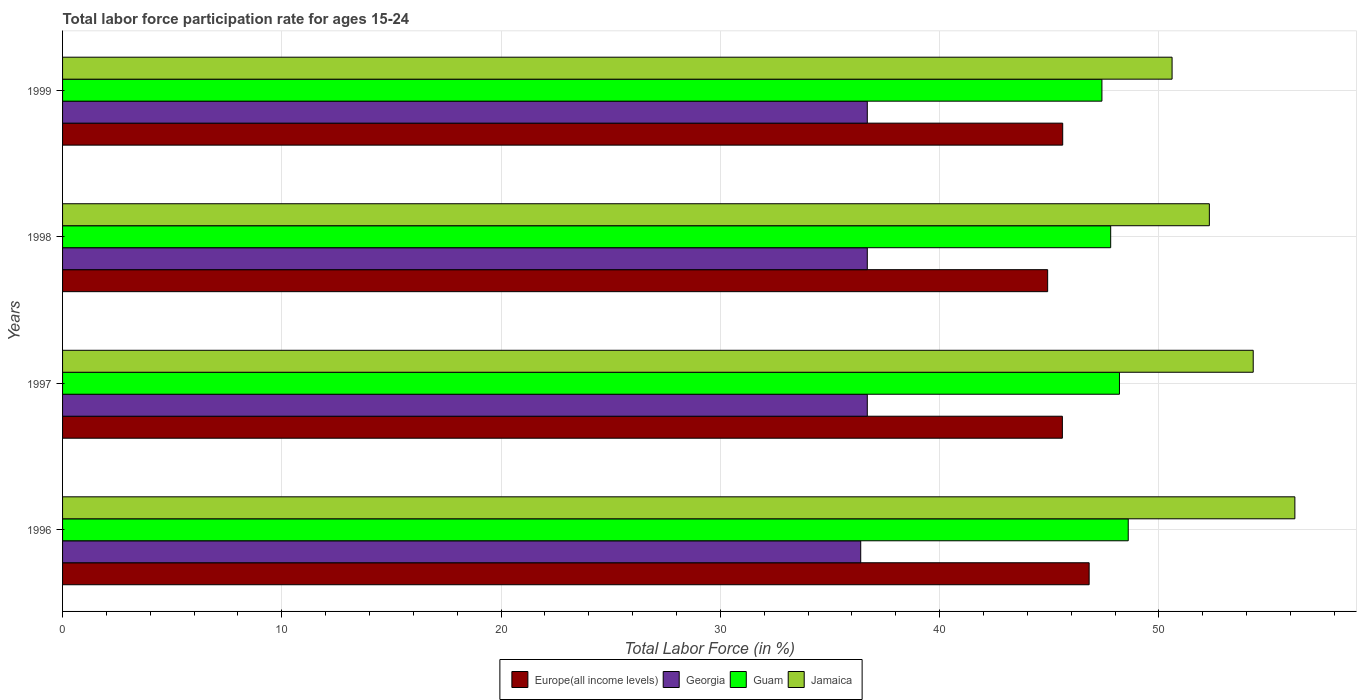Are the number of bars on each tick of the Y-axis equal?
Make the answer very short. Yes. What is the label of the 4th group of bars from the top?
Provide a short and direct response. 1996. What is the labor force participation rate in Georgia in 1996?
Ensure brevity in your answer.  36.4. Across all years, what is the maximum labor force participation rate in Guam?
Your answer should be compact. 48.6. Across all years, what is the minimum labor force participation rate in Guam?
Your response must be concise. 47.4. In which year was the labor force participation rate in Europe(all income levels) maximum?
Your answer should be very brief. 1996. In which year was the labor force participation rate in Guam minimum?
Offer a terse response. 1999. What is the total labor force participation rate in Europe(all income levels) in the graph?
Your answer should be compact. 182.95. What is the difference between the labor force participation rate in Jamaica in 1996 and that in 1997?
Your answer should be very brief. 1.9. What is the difference between the labor force participation rate in Georgia in 1996 and the labor force participation rate in Jamaica in 1998?
Your response must be concise. -15.9. What is the average labor force participation rate in Jamaica per year?
Give a very brief answer. 53.35. In the year 1997, what is the difference between the labor force participation rate in Guam and labor force participation rate in Europe(all income levels)?
Offer a very short reply. 2.6. What is the ratio of the labor force participation rate in Europe(all income levels) in 1996 to that in 1997?
Keep it short and to the point. 1.03. Is the difference between the labor force participation rate in Guam in 1996 and 1999 greater than the difference between the labor force participation rate in Europe(all income levels) in 1996 and 1999?
Your answer should be very brief. No. What is the difference between the highest and the second highest labor force participation rate in Georgia?
Offer a terse response. 0. What is the difference between the highest and the lowest labor force participation rate in Georgia?
Provide a short and direct response. 0.3. Is the sum of the labor force participation rate in Guam in 1996 and 1997 greater than the maximum labor force participation rate in Georgia across all years?
Make the answer very short. Yes. What does the 3rd bar from the top in 1998 represents?
Your response must be concise. Georgia. What does the 3rd bar from the bottom in 1997 represents?
Your answer should be compact. Guam. How many bars are there?
Offer a terse response. 16. Are all the bars in the graph horizontal?
Your answer should be compact. Yes. What is the difference between two consecutive major ticks on the X-axis?
Your answer should be compact. 10. Does the graph contain grids?
Give a very brief answer. Yes. What is the title of the graph?
Provide a succinct answer. Total labor force participation rate for ages 15-24. What is the label or title of the X-axis?
Your answer should be very brief. Total Labor Force (in %). What is the label or title of the Y-axis?
Offer a terse response. Years. What is the Total Labor Force (in %) in Europe(all income levels) in 1996?
Your answer should be compact. 46.82. What is the Total Labor Force (in %) in Georgia in 1996?
Make the answer very short. 36.4. What is the Total Labor Force (in %) of Guam in 1996?
Provide a succinct answer. 48.6. What is the Total Labor Force (in %) in Jamaica in 1996?
Your answer should be compact. 56.2. What is the Total Labor Force (in %) in Europe(all income levels) in 1997?
Your response must be concise. 45.6. What is the Total Labor Force (in %) of Georgia in 1997?
Keep it short and to the point. 36.7. What is the Total Labor Force (in %) of Guam in 1997?
Provide a short and direct response. 48.2. What is the Total Labor Force (in %) in Jamaica in 1997?
Ensure brevity in your answer.  54.3. What is the Total Labor Force (in %) of Europe(all income levels) in 1998?
Offer a very short reply. 44.93. What is the Total Labor Force (in %) of Georgia in 1998?
Ensure brevity in your answer.  36.7. What is the Total Labor Force (in %) of Guam in 1998?
Make the answer very short. 47.8. What is the Total Labor Force (in %) of Jamaica in 1998?
Your response must be concise. 52.3. What is the Total Labor Force (in %) of Europe(all income levels) in 1999?
Your answer should be very brief. 45.61. What is the Total Labor Force (in %) in Georgia in 1999?
Provide a short and direct response. 36.7. What is the Total Labor Force (in %) of Guam in 1999?
Provide a short and direct response. 47.4. What is the Total Labor Force (in %) of Jamaica in 1999?
Keep it short and to the point. 50.6. Across all years, what is the maximum Total Labor Force (in %) of Europe(all income levels)?
Offer a very short reply. 46.82. Across all years, what is the maximum Total Labor Force (in %) of Georgia?
Provide a short and direct response. 36.7. Across all years, what is the maximum Total Labor Force (in %) of Guam?
Your response must be concise. 48.6. Across all years, what is the maximum Total Labor Force (in %) in Jamaica?
Make the answer very short. 56.2. Across all years, what is the minimum Total Labor Force (in %) of Europe(all income levels)?
Offer a very short reply. 44.93. Across all years, what is the minimum Total Labor Force (in %) in Georgia?
Your response must be concise. 36.4. Across all years, what is the minimum Total Labor Force (in %) of Guam?
Your answer should be compact. 47.4. Across all years, what is the minimum Total Labor Force (in %) in Jamaica?
Your answer should be compact. 50.6. What is the total Total Labor Force (in %) in Europe(all income levels) in the graph?
Your response must be concise. 182.95. What is the total Total Labor Force (in %) in Georgia in the graph?
Provide a short and direct response. 146.5. What is the total Total Labor Force (in %) in Guam in the graph?
Keep it short and to the point. 192. What is the total Total Labor Force (in %) of Jamaica in the graph?
Ensure brevity in your answer.  213.4. What is the difference between the Total Labor Force (in %) of Europe(all income levels) in 1996 and that in 1997?
Offer a very short reply. 1.22. What is the difference between the Total Labor Force (in %) of Jamaica in 1996 and that in 1997?
Your response must be concise. 1.9. What is the difference between the Total Labor Force (in %) of Europe(all income levels) in 1996 and that in 1998?
Your answer should be compact. 1.89. What is the difference between the Total Labor Force (in %) in Georgia in 1996 and that in 1998?
Provide a short and direct response. -0.3. What is the difference between the Total Labor Force (in %) in Guam in 1996 and that in 1998?
Offer a very short reply. 0.8. What is the difference between the Total Labor Force (in %) of Europe(all income levels) in 1996 and that in 1999?
Offer a very short reply. 1.21. What is the difference between the Total Labor Force (in %) of Georgia in 1996 and that in 1999?
Provide a succinct answer. -0.3. What is the difference between the Total Labor Force (in %) of Guam in 1996 and that in 1999?
Provide a short and direct response. 1.2. What is the difference between the Total Labor Force (in %) of Jamaica in 1996 and that in 1999?
Provide a short and direct response. 5.6. What is the difference between the Total Labor Force (in %) of Europe(all income levels) in 1997 and that in 1998?
Ensure brevity in your answer.  0.67. What is the difference between the Total Labor Force (in %) of Georgia in 1997 and that in 1998?
Offer a very short reply. 0. What is the difference between the Total Labor Force (in %) of Guam in 1997 and that in 1998?
Your response must be concise. 0.4. What is the difference between the Total Labor Force (in %) of Jamaica in 1997 and that in 1998?
Your response must be concise. 2. What is the difference between the Total Labor Force (in %) in Europe(all income levels) in 1997 and that in 1999?
Offer a terse response. -0.01. What is the difference between the Total Labor Force (in %) in Guam in 1997 and that in 1999?
Keep it short and to the point. 0.8. What is the difference between the Total Labor Force (in %) of Europe(all income levels) in 1998 and that in 1999?
Make the answer very short. -0.69. What is the difference between the Total Labor Force (in %) of Georgia in 1998 and that in 1999?
Give a very brief answer. 0. What is the difference between the Total Labor Force (in %) of Jamaica in 1998 and that in 1999?
Offer a terse response. 1.7. What is the difference between the Total Labor Force (in %) of Europe(all income levels) in 1996 and the Total Labor Force (in %) of Georgia in 1997?
Provide a succinct answer. 10.12. What is the difference between the Total Labor Force (in %) in Europe(all income levels) in 1996 and the Total Labor Force (in %) in Guam in 1997?
Provide a short and direct response. -1.38. What is the difference between the Total Labor Force (in %) of Europe(all income levels) in 1996 and the Total Labor Force (in %) of Jamaica in 1997?
Provide a succinct answer. -7.48. What is the difference between the Total Labor Force (in %) of Georgia in 1996 and the Total Labor Force (in %) of Jamaica in 1997?
Your answer should be compact. -17.9. What is the difference between the Total Labor Force (in %) of Europe(all income levels) in 1996 and the Total Labor Force (in %) of Georgia in 1998?
Your answer should be compact. 10.12. What is the difference between the Total Labor Force (in %) of Europe(all income levels) in 1996 and the Total Labor Force (in %) of Guam in 1998?
Your response must be concise. -0.98. What is the difference between the Total Labor Force (in %) of Europe(all income levels) in 1996 and the Total Labor Force (in %) of Jamaica in 1998?
Provide a short and direct response. -5.48. What is the difference between the Total Labor Force (in %) in Georgia in 1996 and the Total Labor Force (in %) in Jamaica in 1998?
Your answer should be compact. -15.9. What is the difference between the Total Labor Force (in %) of Guam in 1996 and the Total Labor Force (in %) of Jamaica in 1998?
Give a very brief answer. -3.7. What is the difference between the Total Labor Force (in %) in Europe(all income levels) in 1996 and the Total Labor Force (in %) in Georgia in 1999?
Your answer should be very brief. 10.12. What is the difference between the Total Labor Force (in %) of Europe(all income levels) in 1996 and the Total Labor Force (in %) of Guam in 1999?
Provide a short and direct response. -0.58. What is the difference between the Total Labor Force (in %) of Europe(all income levels) in 1996 and the Total Labor Force (in %) of Jamaica in 1999?
Your answer should be very brief. -3.78. What is the difference between the Total Labor Force (in %) in Guam in 1996 and the Total Labor Force (in %) in Jamaica in 1999?
Your answer should be very brief. -2. What is the difference between the Total Labor Force (in %) of Europe(all income levels) in 1997 and the Total Labor Force (in %) of Georgia in 1998?
Ensure brevity in your answer.  8.9. What is the difference between the Total Labor Force (in %) of Europe(all income levels) in 1997 and the Total Labor Force (in %) of Guam in 1998?
Your answer should be very brief. -2.2. What is the difference between the Total Labor Force (in %) in Europe(all income levels) in 1997 and the Total Labor Force (in %) in Jamaica in 1998?
Ensure brevity in your answer.  -6.7. What is the difference between the Total Labor Force (in %) of Georgia in 1997 and the Total Labor Force (in %) of Jamaica in 1998?
Your answer should be very brief. -15.6. What is the difference between the Total Labor Force (in %) of Europe(all income levels) in 1997 and the Total Labor Force (in %) of Georgia in 1999?
Your answer should be very brief. 8.9. What is the difference between the Total Labor Force (in %) of Europe(all income levels) in 1997 and the Total Labor Force (in %) of Guam in 1999?
Make the answer very short. -1.8. What is the difference between the Total Labor Force (in %) of Europe(all income levels) in 1997 and the Total Labor Force (in %) of Jamaica in 1999?
Offer a very short reply. -5. What is the difference between the Total Labor Force (in %) of Georgia in 1997 and the Total Labor Force (in %) of Guam in 1999?
Provide a succinct answer. -10.7. What is the difference between the Total Labor Force (in %) of Georgia in 1997 and the Total Labor Force (in %) of Jamaica in 1999?
Provide a succinct answer. -13.9. What is the difference between the Total Labor Force (in %) of Guam in 1997 and the Total Labor Force (in %) of Jamaica in 1999?
Give a very brief answer. -2.4. What is the difference between the Total Labor Force (in %) in Europe(all income levels) in 1998 and the Total Labor Force (in %) in Georgia in 1999?
Make the answer very short. 8.23. What is the difference between the Total Labor Force (in %) of Europe(all income levels) in 1998 and the Total Labor Force (in %) of Guam in 1999?
Your answer should be compact. -2.47. What is the difference between the Total Labor Force (in %) in Europe(all income levels) in 1998 and the Total Labor Force (in %) in Jamaica in 1999?
Provide a succinct answer. -5.67. What is the difference between the Total Labor Force (in %) in Georgia in 1998 and the Total Labor Force (in %) in Jamaica in 1999?
Make the answer very short. -13.9. What is the difference between the Total Labor Force (in %) of Guam in 1998 and the Total Labor Force (in %) of Jamaica in 1999?
Provide a succinct answer. -2.8. What is the average Total Labor Force (in %) of Europe(all income levels) per year?
Offer a terse response. 45.74. What is the average Total Labor Force (in %) of Georgia per year?
Your answer should be compact. 36.62. What is the average Total Labor Force (in %) of Jamaica per year?
Make the answer very short. 53.35. In the year 1996, what is the difference between the Total Labor Force (in %) of Europe(all income levels) and Total Labor Force (in %) of Georgia?
Offer a terse response. 10.42. In the year 1996, what is the difference between the Total Labor Force (in %) in Europe(all income levels) and Total Labor Force (in %) in Guam?
Ensure brevity in your answer.  -1.78. In the year 1996, what is the difference between the Total Labor Force (in %) in Europe(all income levels) and Total Labor Force (in %) in Jamaica?
Keep it short and to the point. -9.38. In the year 1996, what is the difference between the Total Labor Force (in %) of Georgia and Total Labor Force (in %) of Jamaica?
Ensure brevity in your answer.  -19.8. In the year 1997, what is the difference between the Total Labor Force (in %) in Europe(all income levels) and Total Labor Force (in %) in Georgia?
Provide a succinct answer. 8.9. In the year 1997, what is the difference between the Total Labor Force (in %) in Europe(all income levels) and Total Labor Force (in %) in Guam?
Your answer should be very brief. -2.6. In the year 1997, what is the difference between the Total Labor Force (in %) in Europe(all income levels) and Total Labor Force (in %) in Jamaica?
Ensure brevity in your answer.  -8.7. In the year 1997, what is the difference between the Total Labor Force (in %) of Georgia and Total Labor Force (in %) of Jamaica?
Provide a succinct answer. -17.6. In the year 1997, what is the difference between the Total Labor Force (in %) of Guam and Total Labor Force (in %) of Jamaica?
Ensure brevity in your answer.  -6.1. In the year 1998, what is the difference between the Total Labor Force (in %) in Europe(all income levels) and Total Labor Force (in %) in Georgia?
Make the answer very short. 8.23. In the year 1998, what is the difference between the Total Labor Force (in %) of Europe(all income levels) and Total Labor Force (in %) of Guam?
Provide a short and direct response. -2.87. In the year 1998, what is the difference between the Total Labor Force (in %) in Europe(all income levels) and Total Labor Force (in %) in Jamaica?
Ensure brevity in your answer.  -7.37. In the year 1998, what is the difference between the Total Labor Force (in %) of Georgia and Total Labor Force (in %) of Guam?
Your answer should be very brief. -11.1. In the year 1998, what is the difference between the Total Labor Force (in %) in Georgia and Total Labor Force (in %) in Jamaica?
Your answer should be very brief. -15.6. In the year 1998, what is the difference between the Total Labor Force (in %) in Guam and Total Labor Force (in %) in Jamaica?
Give a very brief answer. -4.5. In the year 1999, what is the difference between the Total Labor Force (in %) in Europe(all income levels) and Total Labor Force (in %) in Georgia?
Ensure brevity in your answer.  8.91. In the year 1999, what is the difference between the Total Labor Force (in %) of Europe(all income levels) and Total Labor Force (in %) of Guam?
Your answer should be very brief. -1.79. In the year 1999, what is the difference between the Total Labor Force (in %) of Europe(all income levels) and Total Labor Force (in %) of Jamaica?
Keep it short and to the point. -4.99. In the year 1999, what is the difference between the Total Labor Force (in %) in Georgia and Total Labor Force (in %) in Guam?
Your answer should be very brief. -10.7. What is the ratio of the Total Labor Force (in %) of Europe(all income levels) in 1996 to that in 1997?
Keep it short and to the point. 1.03. What is the ratio of the Total Labor Force (in %) of Georgia in 1996 to that in 1997?
Keep it short and to the point. 0.99. What is the ratio of the Total Labor Force (in %) in Guam in 1996 to that in 1997?
Give a very brief answer. 1.01. What is the ratio of the Total Labor Force (in %) of Jamaica in 1996 to that in 1997?
Offer a terse response. 1.03. What is the ratio of the Total Labor Force (in %) of Europe(all income levels) in 1996 to that in 1998?
Offer a very short reply. 1.04. What is the ratio of the Total Labor Force (in %) in Georgia in 1996 to that in 1998?
Offer a very short reply. 0.99. What is the ratio of the Total Labor Force (in %) in Guam in 1996 to that in 1998?
Make the answer very short. 1.02. What is the ratio of the Total Labor Force (in %) in Jamaica in 1996 to that in 1998?
Your answer should be compact. 1.07. What is the ratio of the Total Labor Force (in %) of Europe(all income levels) in 1996 to that in 1999?
Keep it short and to the point. 1.03. What is the ratio of the Total Labor Force (in %) in Georgia in 1996 to that in 1999?
Provide a short and direct response. 0.99. What is the ratio of the Total Labor Force (in %) in Guam in 1996 to that in 1999?
Provide a succinct answer. 1.03. What is the ratio of the Total Labor Force (in %) in Jamaica in 1996 to that in 1999?
Offer a very short reply. 1.11. What is the ratio of the Total Labor Force (in %) in Georgia in 1997 to that in 1998?
Offer a very short reply. 1. What is the ratio of the Total Labor Force (in %) of Guam in 1997 to that in 1998?
Ensure brevity in your answer.  1.01. What is the ratio of the Total Labor Force (in %) in Jamaica in 1997 to that in 1998?
Your response must be concise. 1.04. What is the ratio of the Total Labor Force (in %) of Europe(all income levels) in 1997 to that in 1999?
Make the answer very short. 1. What is the ratio of the Total Labor Force (in %) in Georgia in 1997 to that in 1999?
Make the answer very short. 1. What is the ratio of the Total Labor Force (in %) of Guam in 1997 to that in 1999?
Ensure brevity in your answer.  1.02. What is the ratio of the Total Labor Force (in %) of Jamaica in 1997 to that in 1999?
Your response must be concise. 1.07. What is the ratio of the Total Labor Force (in %) in Georgia in 1998 to that in 1999?
Your answer should be very brief. 1. What is the ratio of the Total Labor Force (in %) in Guam in 1998 to that in 1999?
Provide a succinct answer. 1.01. What is the ratio of the Total Labor Force (in %) in Jamaica in 1998 to that in 1999?
Make the answer very short. 1.03. What is the difference between the highest and the second highest Total Labor Force (in %) in Europe(all income levels)?
Ensure brevity in your answer.  1.21. What is the difference between the highest and the second highest Total Labor Force (in %) of Guam?
Offer a very short reply. 0.4. What is the difference between the highest and the second highest Total Labor Force (in %) of Jamaica?
Your answer should be compact. 1.9. What is the difference between the highest and the lowest Total Labor Force (in %) of Europe(all income levels)?
Ensure brevity in your answer.  1.89. What is the difference between the highest and the lowest Total Labor Force (in %) in Georgia?
Make the answer very short. 0.3. What is the difference between the highest and the lowest Total Labor Force (in %) in Guam?
Make the answer very short. 1.2. 